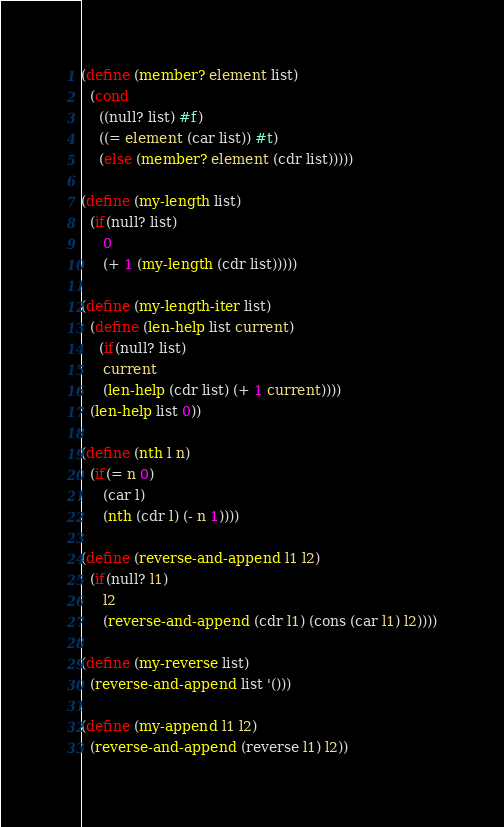<code> <loc_0><loc_0><loc_500><loc_500><_Scheme_>(define (member? element list)
  (cond
    ((null? list) #f)
    ((= element (car list)) #t)
    (else (member? element (cdr list)))))

(define (my-length list)
  (if(null? list)
     0
     (+ 1 (my-length (cdr list)))))

(define (my-length-iter list)
  (define (len-help list current)
    (if(null? list)
     current
     (len-help (cdr list) (+ 1 current))))
  (len-help list 0))

(define (nth l n)
  (if(= n 0)
     (car l)
     (nth (cdr l) (- n 1))))

(define (reverse-and-append l1 l2)
  (if(null? l1)
     l2
     (reverse-and-append (cdr l1) (cons (car l1) l2))))

(define (my-reverse list)
  (reverse-and-append list '()))

(define (my-append l1 l2)
  (reverse-and-append (reverse l1) l2))</code> 